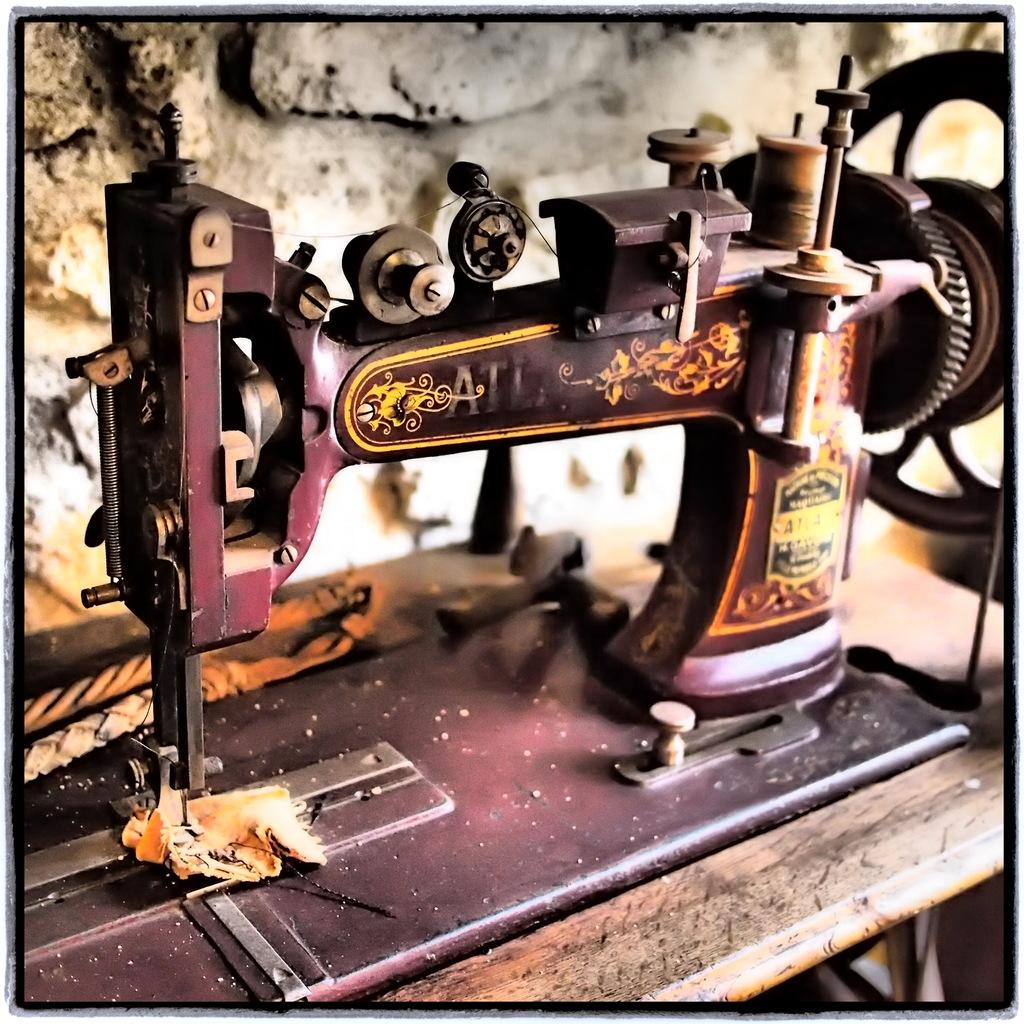What can be said about the nature of the image? The image is edited. What is the main object in the image? There is a sewing machine in the image. What can be seen in the background of the image? There is a wall in the background of the image. What is placed on the sewing machine? A piece of cloth is present on the sewing machine. Are there any other items on the sewing machine? Yes, there are other objects on the sewing machine. What type of glove is being used to operate the sewing machine in the image? There is no glove present in the image, and the sewing machine is not being operated by a person. 